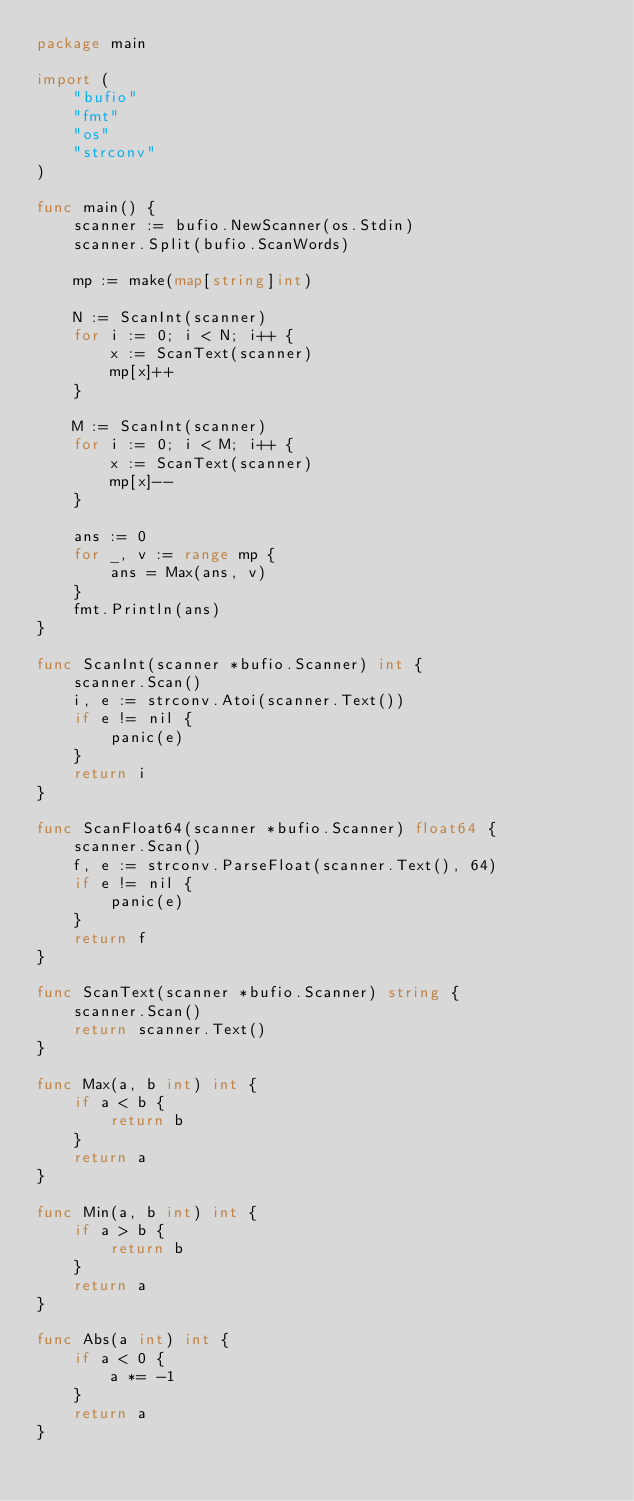Convert code to text. <code><loc_0><loc_0><loc_500><loc_500><_Go_>package main

import (
	"bufio"
	"fmt"
	"os"
	"strconv"
)

func main() {
	scanner := bufio.NewScanner(os.Stdin)
	scanner.Split(bufio.ScanWords)
	
	mp := make(map[string]int)
	
	N := ScanInt(scanner)
	for i := 0; i < N; i++ {
	    x := ScanText(scanner)
	    mp[x]++
	}
	
	M := ScanInt(scanner)
	for i := 0; i < M; i++ {
	    x := ScanText(scanner)
	    mp[x]--
	}
	
	ans := 0
	for _, v := range mp {
	    ans = Max(ans, v)
	}
	fmt.Println(ans)
}

func ScanInt(scanner *bufio.Scanner) int {
	scanner.Scan()
	i, e := strconv.Atoi(scanner.Text())
	if e != nil {
		panic(e)
	}
	return i
}

func ScanFloat64(scanner *bufio.Scanner) float64 {
	scanner.Scan()
	f, e := strconv.ParseFloat(scanner.Text(), 64)
	if e != nil {
		panic(e)
	}
	return f
}

func ScanText(scanner *bufio.Scanner) string {
	scanner.Scan()
	return scanner.Text()
}

func Max(a, b int) int {
	if a < b {
		return b
	}
	return a
}

func Min(a, b int) int {
	if a > b {
		return b
	}
	return a
}

func Abs(a int) int {
	if a < 0 {
		a *= -1
	}
	return a
}
 </code> 